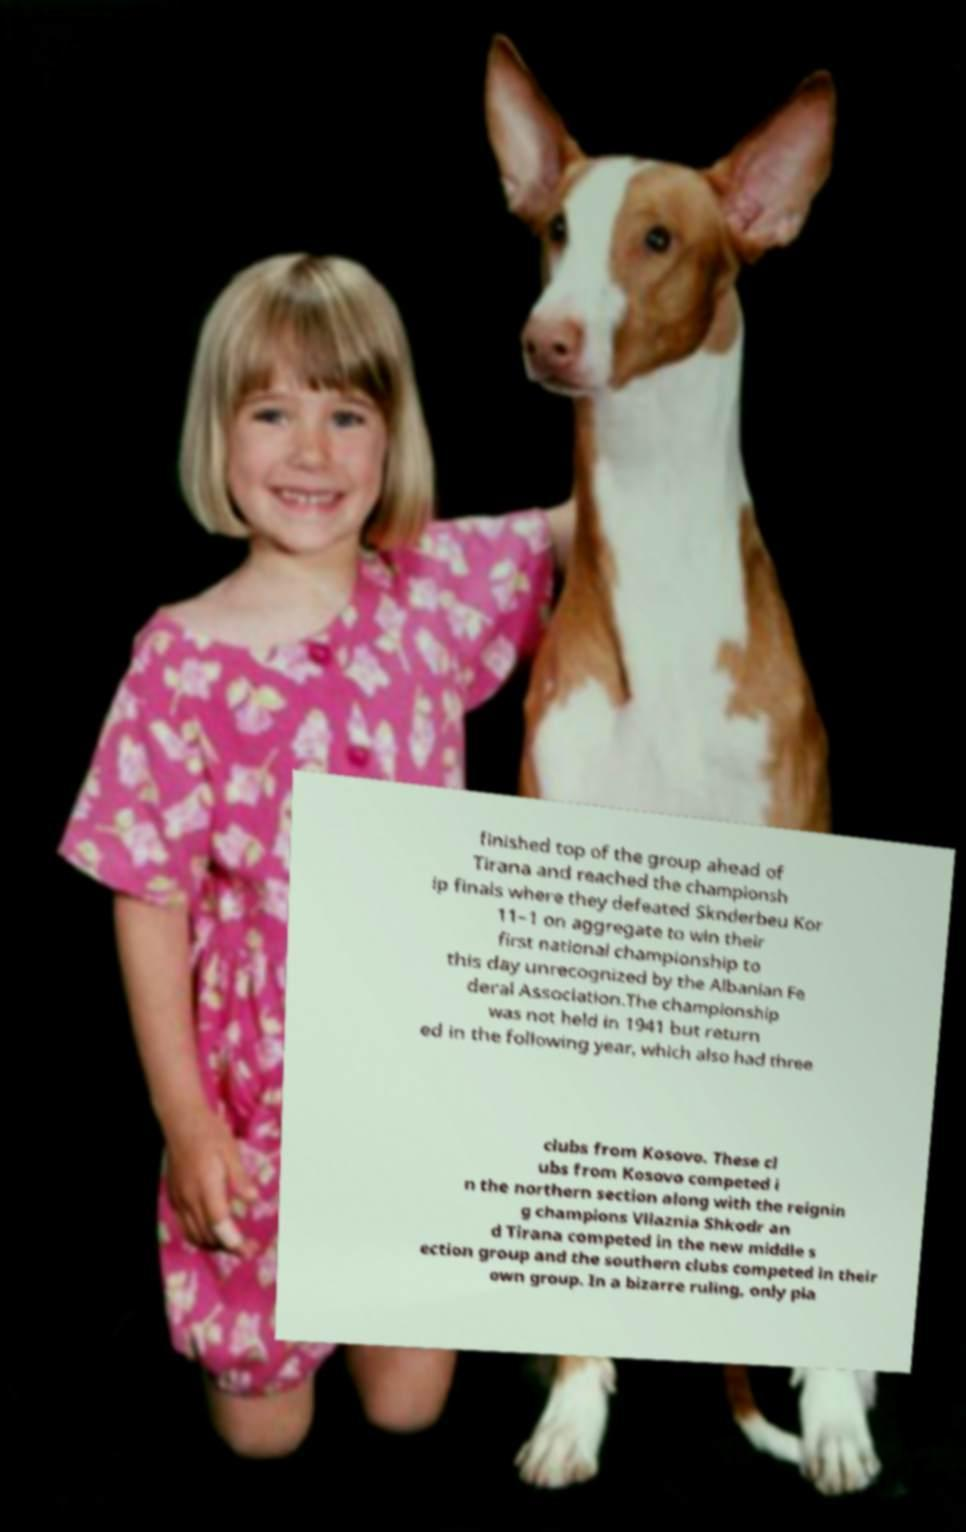Please identify and transcribe the text found in this image. finished top of the group ahead of Tirana and reached the championsh ip finals where they defeated Sknderbeu Kor 11–1 on aggregate to win their first national championship to this day unrecognized by the Albanian Fe deral Association.The championship was not held in 1941 but return ed in the following year, which also had three clubs from Kosovo. These cl ubs from Kosovo competed i n the northern section along with the reignin g champions Vllaznia Shkodr an d Tirana competed in the new middle s ection group and the southern clubs competed in their own group. In a bizarre ruling, only pla 